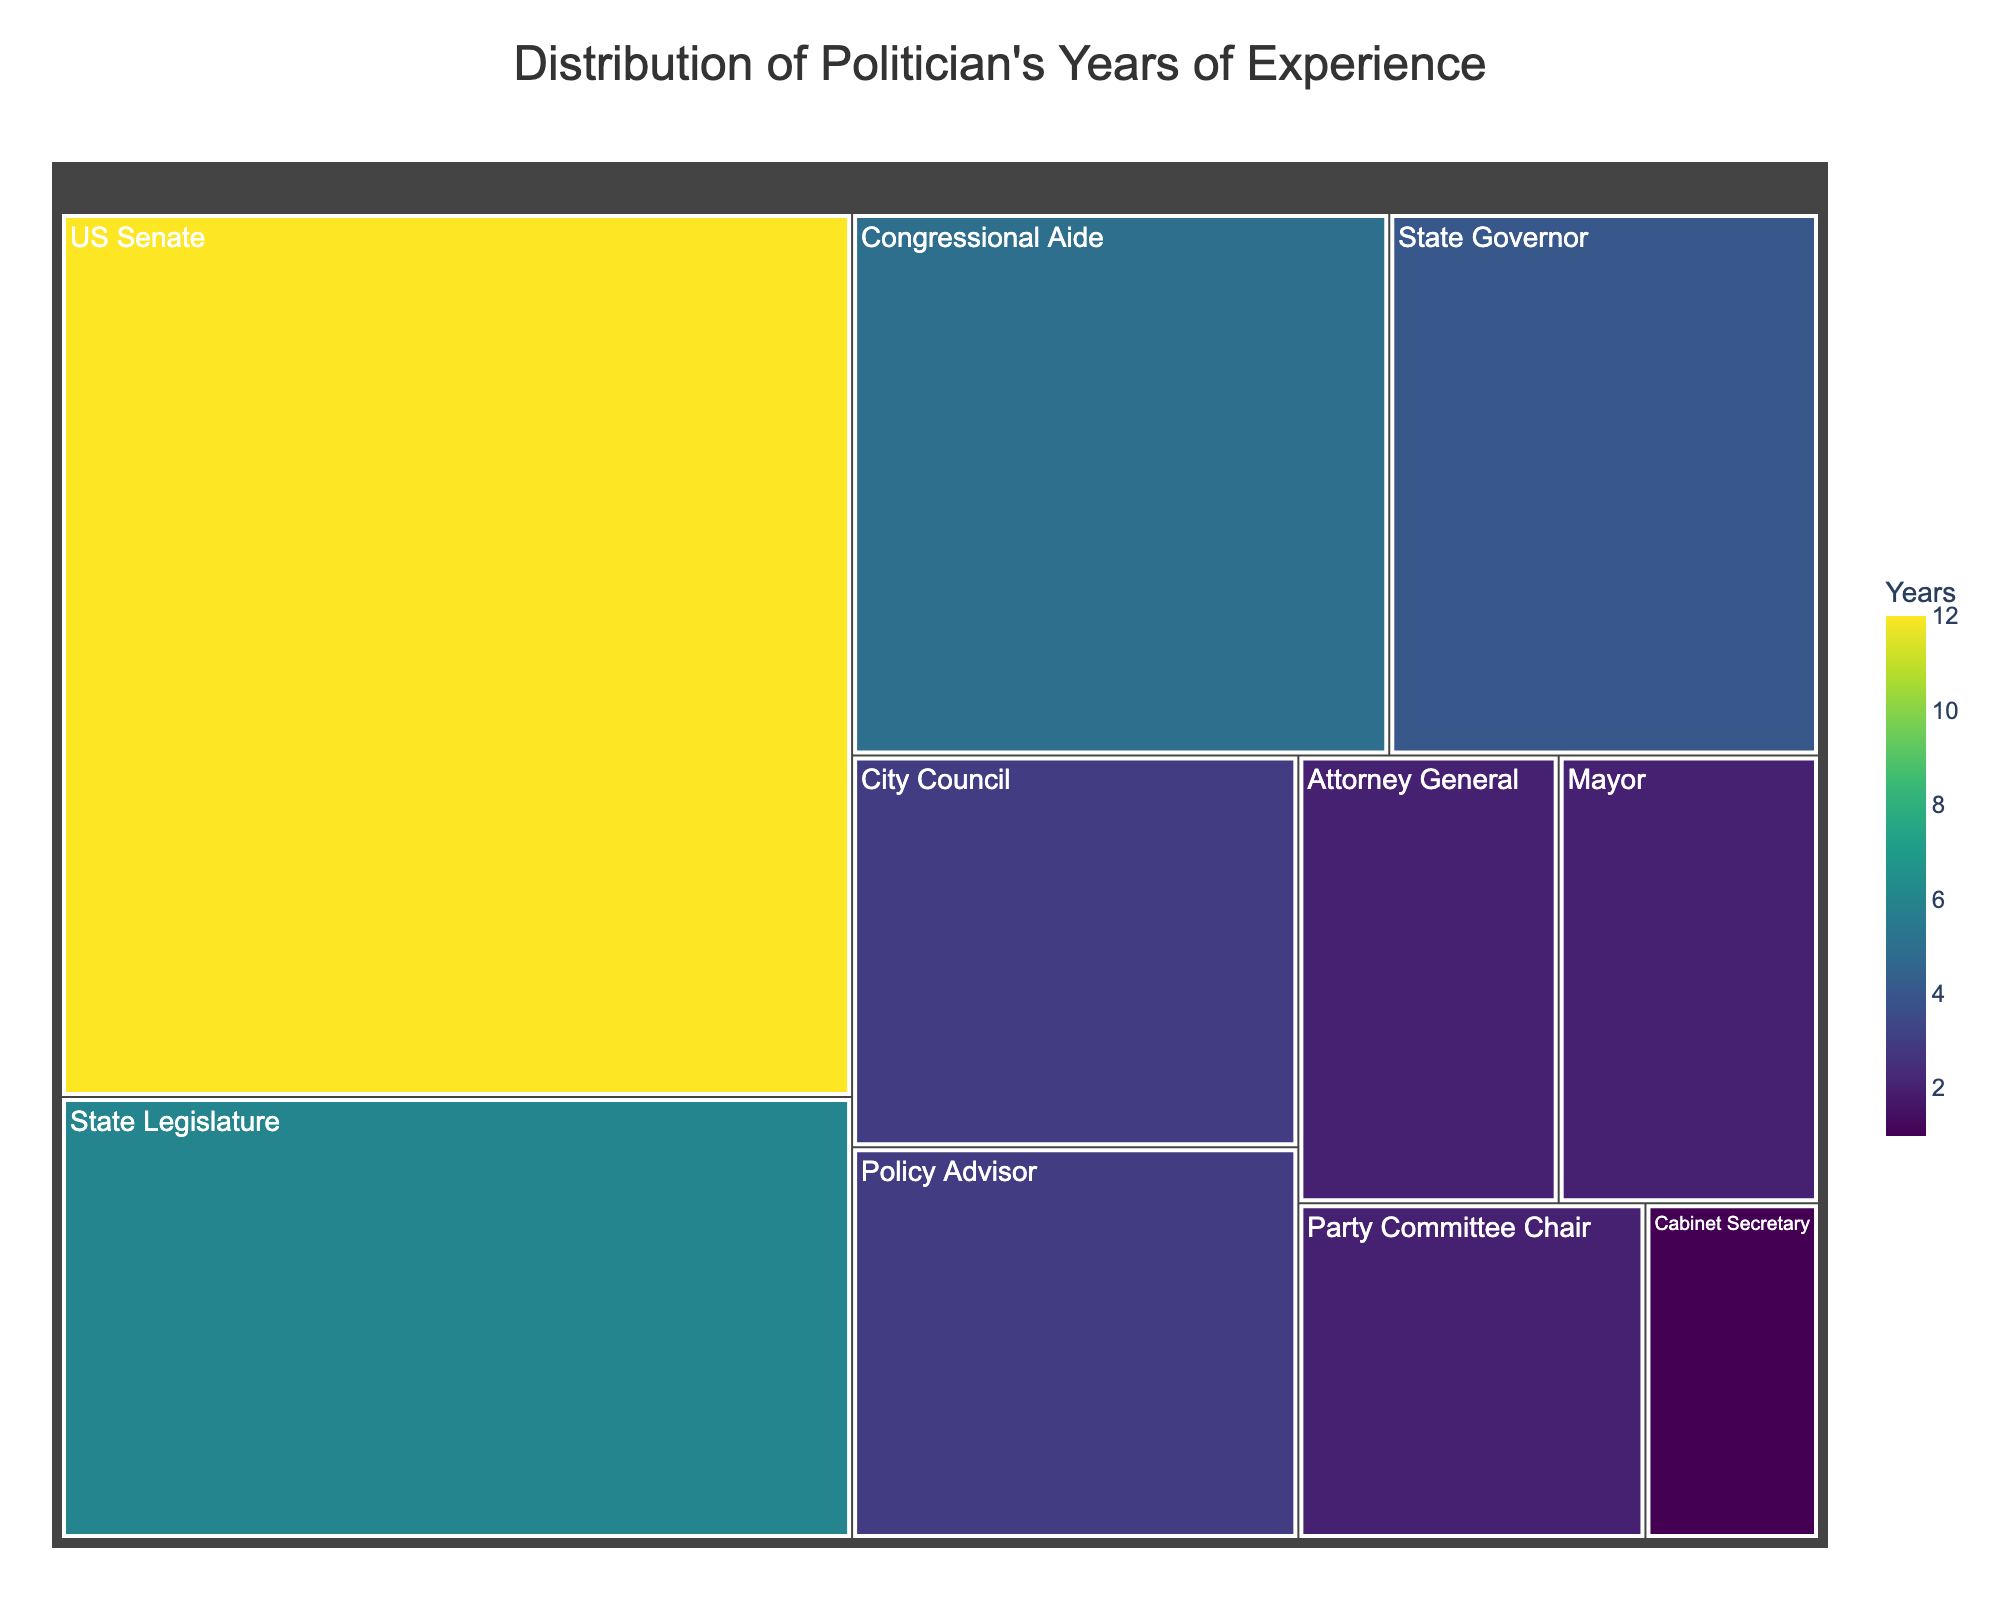What office does the politician have the most years of experience in? Look at the different sections of the treemap. The largest segment represents the office with the most years. Here, the largest section is labeled "US Senate" with 12 years.
Answer: US Senate What is the total number of years the politician has spent in state-level positions? Identify the positions associated with state-level roles: State Governor and State Legislature. Add their years: 4 (State Governor) + 6 (State Legislature) = 10 years.
Answer: 10 years Which office has the fewest years of experience? Identify the smallest section on the treemap. The smallest section is "Cabinet Secretary" with 1 year.
Answer: Cabinet Secretary How many years of experience does the politician have in city positions (City Council and Mayor)? Locate and sum the years for the City Council and Mayor positions. City Council has 3 years and Mayor has 2 years, combined they are 3 + 2 = 5 years.
Answer: 5 years How does the experience in the State Legislature compare to the experience as a Policy Advisor? Find the sections labeled "State Legislature" and "Policy Advisor". The State Legislature has 6 years and the Policy Advisor has 3 years, so the State Legislature has more experience.
Answer: State Legislature Are the years of experience as an Attorney General and Mayor equal? Compare the sections for Attorney General and Mayor. Both sections are labeled with 2 years.
Answer: Yes If we combine the years of experience as a Congressional Aide and Policy Advisor, does it exceed the time served in the US Senate? Identify the years for Congressional Aide and Policy Advisor, which are 5 and 3 respectively. Sum these values, 5 + 3 = 8 years. Compare it to the 12 years in the US Senate, and 8 < 12.
Answer: No What's the average number of years the politician has in the roles listed? Add all years of experience: 12 + 4 + 6 + 3 + 2 + 5 + 3 + 2 + 1 + 2 = 40. There are 10 roles, so the average is 40 / 10 = 4 years.
Answer: 4 years What color represents the position with the most years of experience? The color in the treemap for the largest section, "US Senate," is typically the darkest shade in the "Viridis" color scale due to the longest duration of 12 years.
Answer: Darkest shade In which positions does the politician have more than 5 years of experience? Identify the sections with values greater than 5. The sections are "US Senate" with 12 years and "State Legislature" with 6 years.
Answer: US Senate, State Legislature 